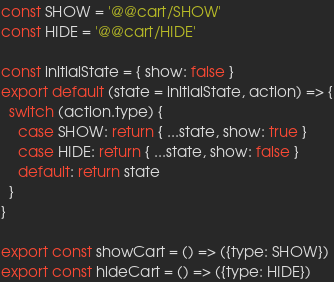Convert code to text. <code><loc_0><loc_0><loc_500><loc_500><_JavaScript_>const SHOW = '@@cart/SHOW'
const HIDE = '@@cart/HIDE'

const initialState = { show: false }
export default (state = initialState, action) => {
  switch (action.type) {
    case SHOW: return { ...state, show: true }
    case HIDE: return { ...state, show: false }
    default: return state
  }
}

export const showCart = () => ({type: SHOW})
export const hideCart = () => ({type: HIDE})
</code> 